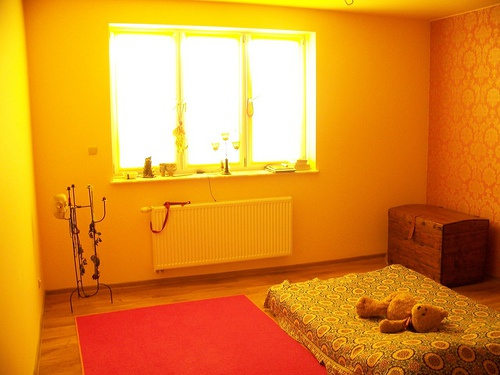Describe the objects in this image and their specific colors. I can see bed in orange, red, and maroon tones and teddy bear in orange, maroon, and red tones in this image. 